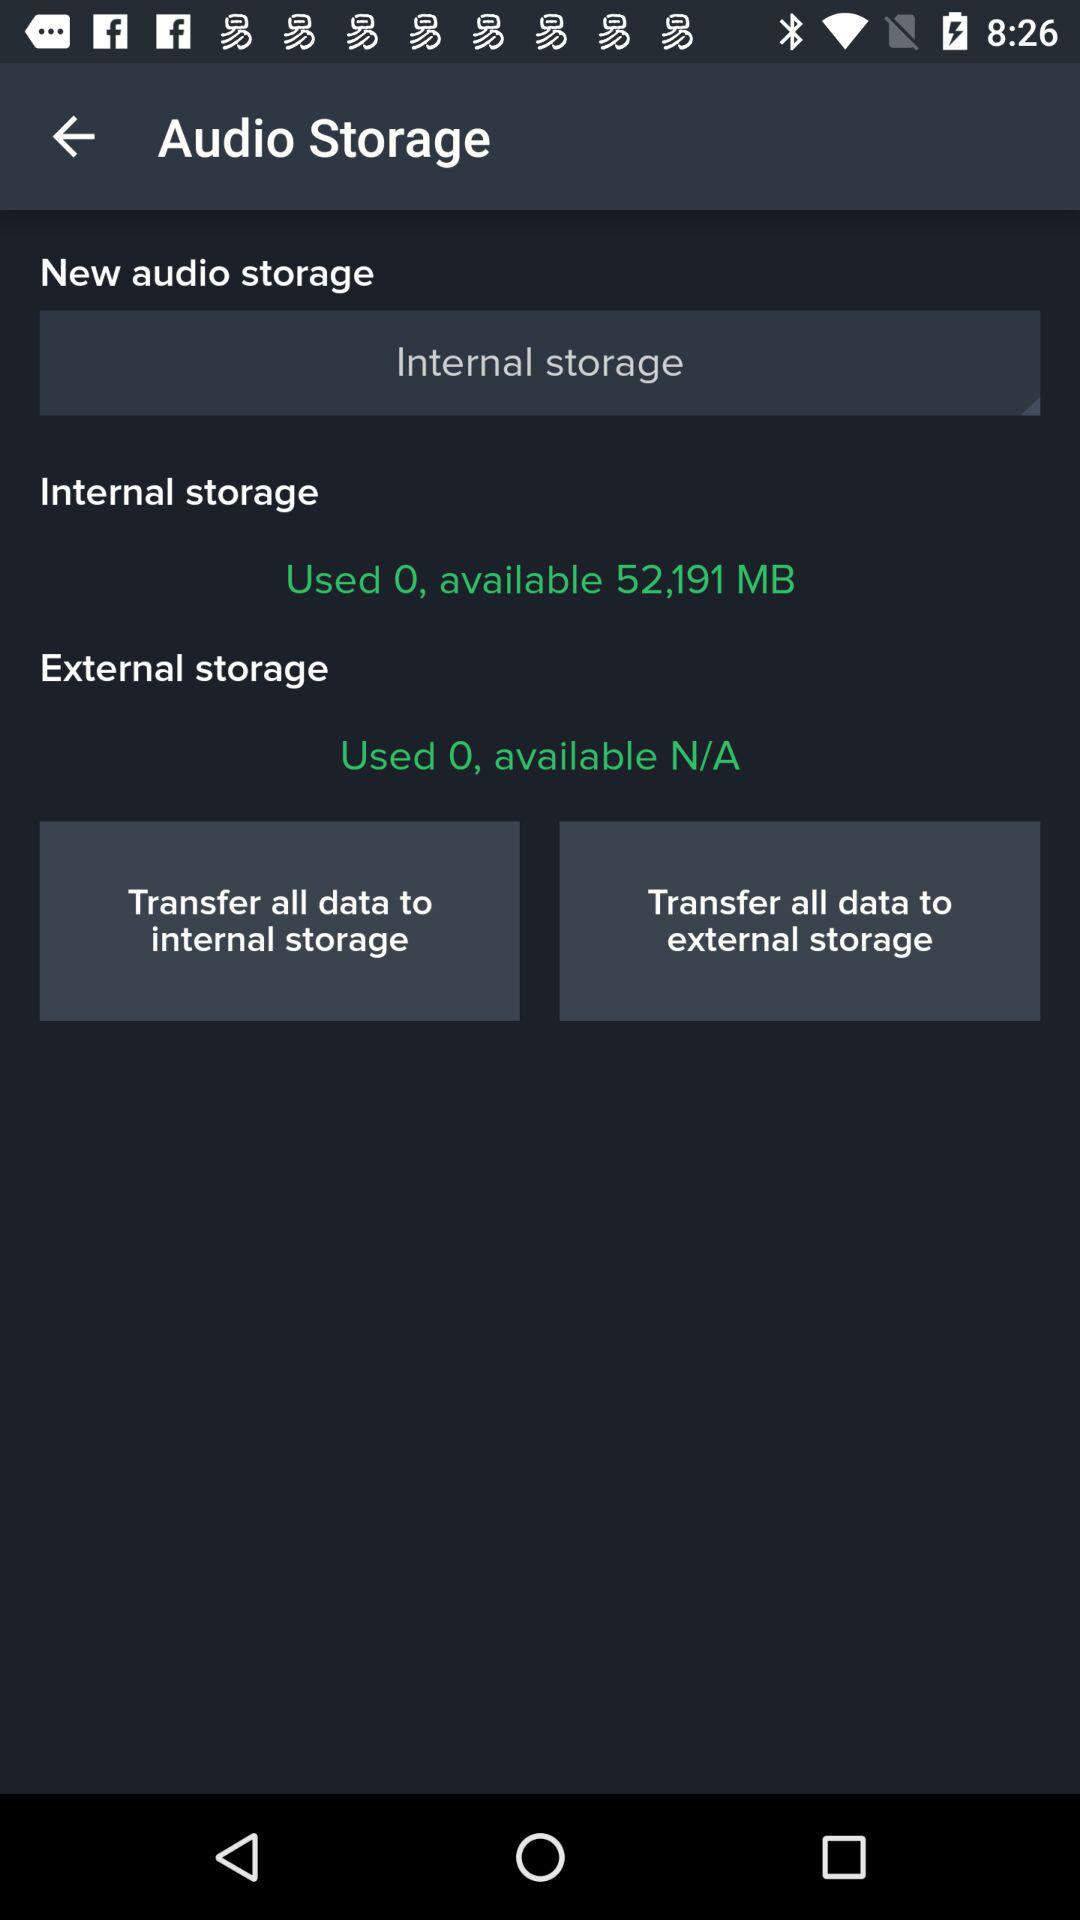How much external storage is available? The external storage is N/A. 